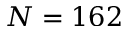<formula> <loc_0><loc_0><loc_500><loc_500>N = 1 6 2</formula> 